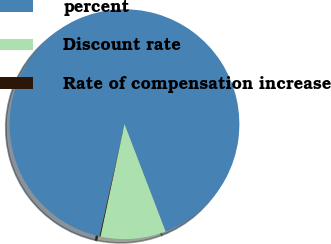Convert chart to OTSL. <chart><loc_0><loc_0><loc_500><loc_500><pie_chart><fcel>percent<fcel>Discount rate<fcel>Rate of compensation increase<nl><fcel>90.69%<fcel>9.18%<fcel>0.13%<nl></chart> 